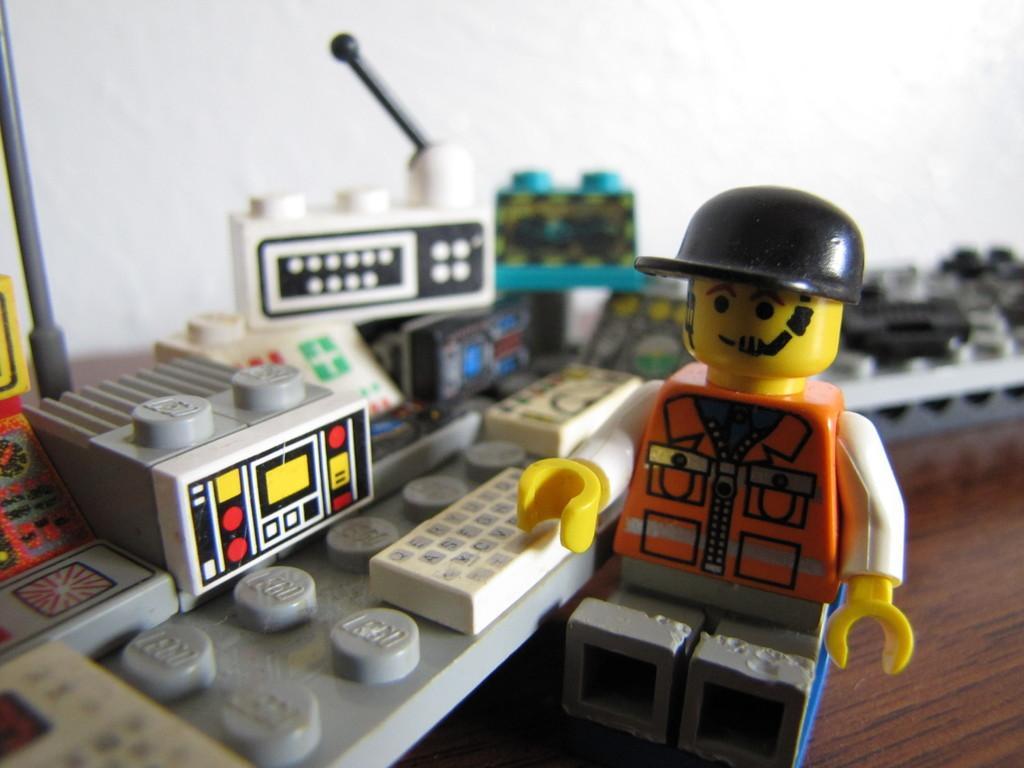Can you describe this image briefly? In this image there is a table and we can see legos and a toy placed on the table. In the background there is a wall. 